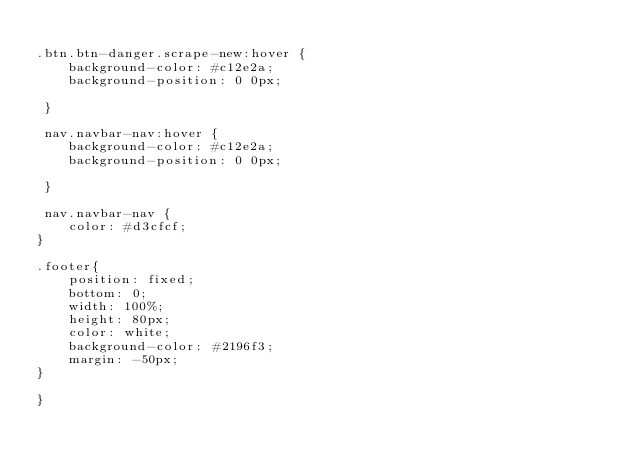<code> <loc_0><loc_0><loc_500><loc_500><_CSS_>
.btn.btn-danger.scrape-new:hover {
    background-color: #c12e2a;
    background-position: 0 0px;

 }

 nav.navbar-nav:hover {
    background-color: #c12e2a;
    background-position: 0 0px;

 }

 nav.navbar-nav {
    color: #d3cfcf;
}

.footer{
    position: fixed;
    bottom: 0;
    width: 100%;
    height: 80px;
    color: white;
    background-color: #2196f3;
    margin: -50px;
}

}</code> 